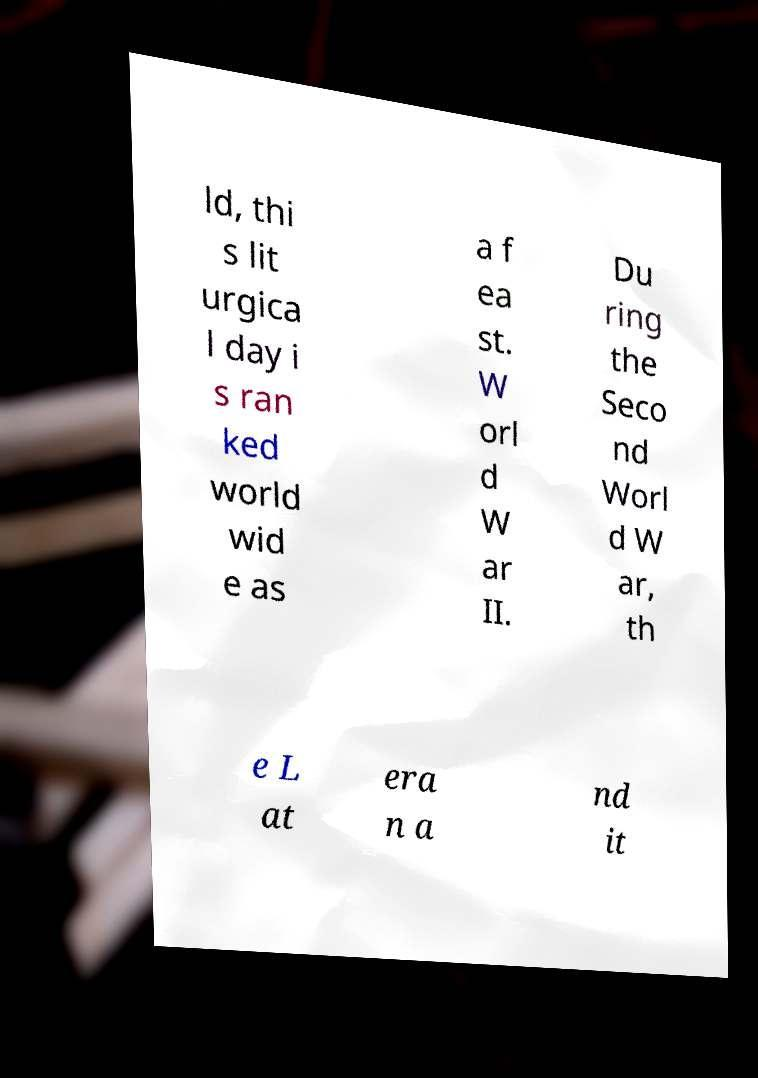Can you accurately transcribe the text from the provided image for me? ld, thi s lit urgica l day i s ran ked world wid e as a f ea st. W orl d W ar II. Du ring the Seco nd Worl d W ar, th e L at era n a nd it 